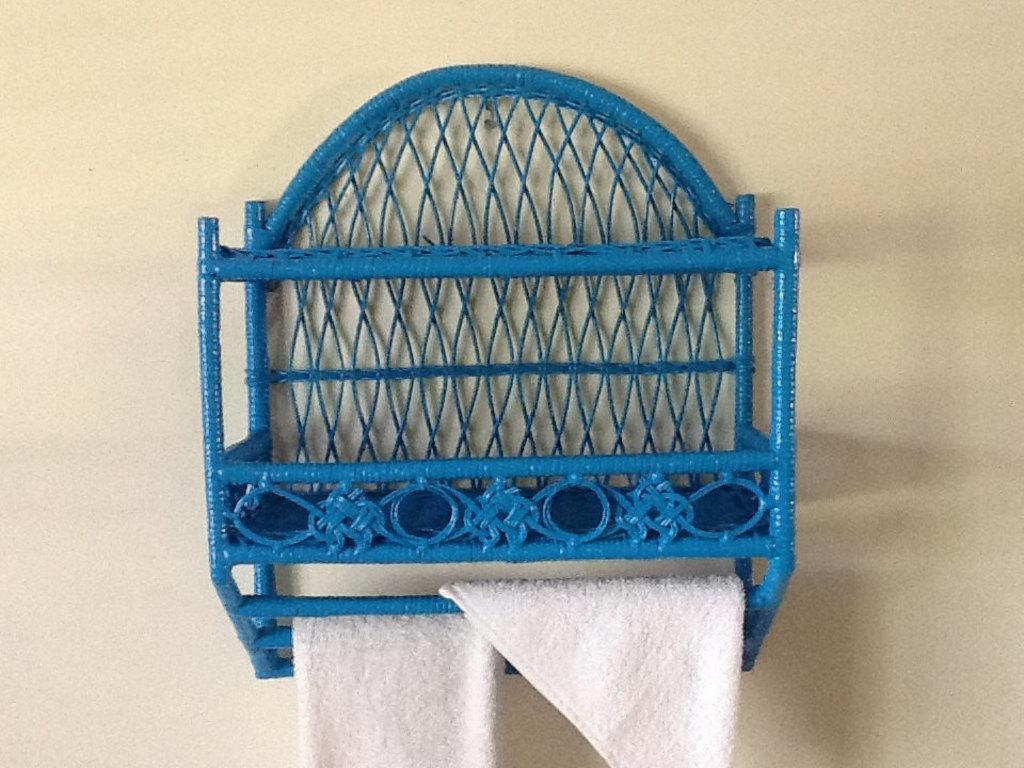What type of shelf is in the picture? There is a wicker shelf in the picture. Where is the wicker shelf located? The wicker shelf is on the wall. What items can be seen on the wicker shelf? There are two napkins on the shelf. What type of zinc object is visible on the wicker shelf? There is no zinc object present on the wicker shelf in the image. 